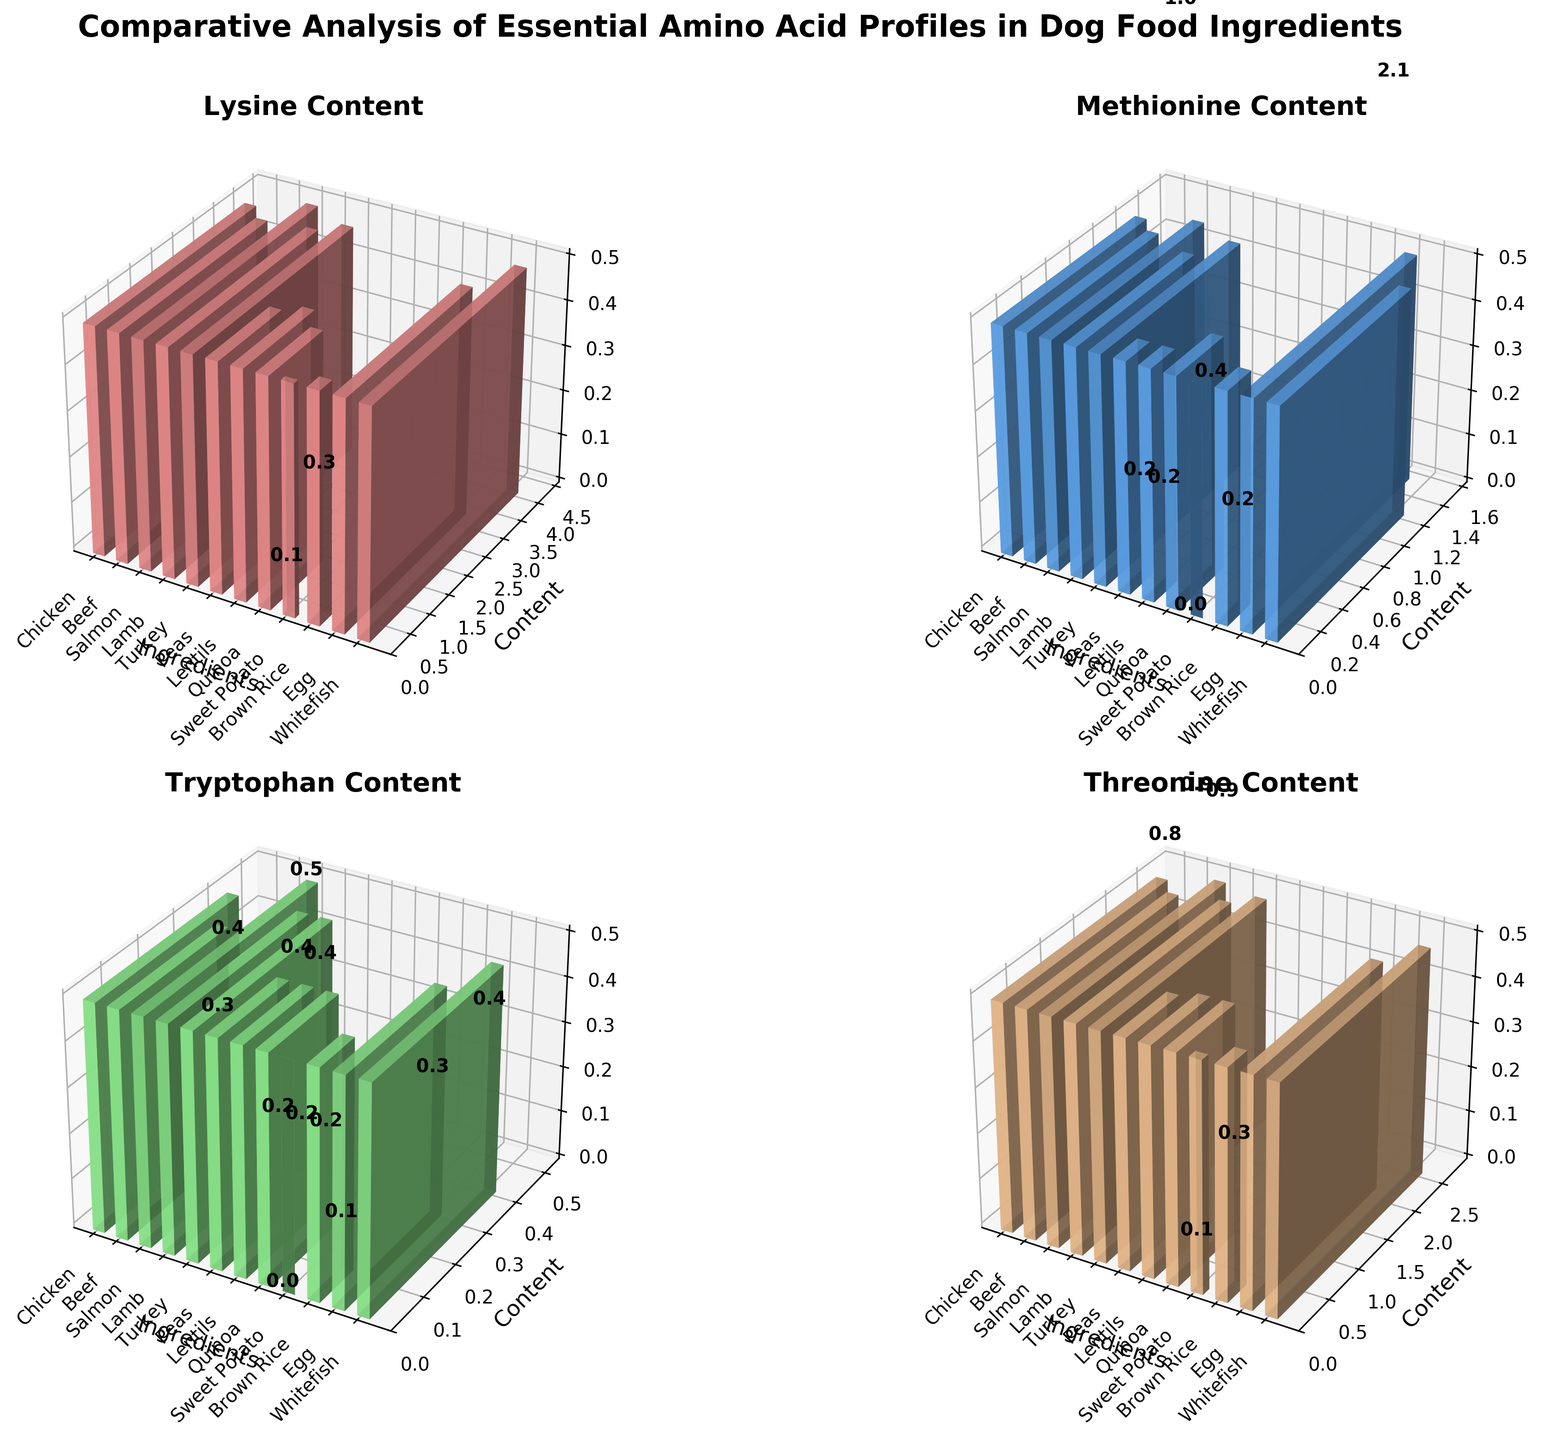What are the ingredient labels on the x-axis for the Lysine subplot? The Lysine subplot shows ingredients on the x-axis: Chicken, Beef, Salmon, Lamb, Turkey, Peas, Lentils, Quinoa, Sweet Potato, Brown Rice, Egg, and Whitefish.
Answer: Chicken, Beef, Salmon, Lamb, Turkey, Peas, Lentils, Quinoa, Sweet Potato, Brown Rice, Egg, Whitefish Which ingredient has the highest Threonine content? In the Threonine subplot, the bar for Salmon is the highest.
Answer: Salmon How does the Methionine content of Whitefish compare to that of Peas? In the Methionine subplot, the bar representing Whitefish is higher than the bar for Peas.
Answer: Whitefish is higher What is the average Lysine content across all ingredients? Sum the Lysine values (3.8 + 3.5 + 4.2 + 3.6 + 3.9 + 1.5 + 1.7 + 1.3 + 0.1 + 0.3 + 3.2 + 4.0 = 31.1) and divide by the number of ingredients (12). The average is 31.1 / 12.
Answer: 2.59 Compare the Tryptophan content between Beef and Lamb. Which is higher and by how much? From the Tryptophan subplot, Beef has 0.3 and Lamb has 0.4. The difference is 0.4 - 0.3 = 0.1. Lamb is higher by 0.1.
Answer: Lamb by 0.1 What is the total Methionine content for all plant-based ingredients? Sum the Methionine values for Peas, Lentils, Quinoa, Sweet Potato, and Brown Rice (0.2 + 0.2 + 0.4 + 0.0 + 0.2 = 1.0).
Answer: 1.0 Which amino acid has the smallest range of values across all ingredients? Calculate the range for each amino acid: Lysine (4.2 - 0.1 = 4.1), Methionine (1.5 - 0.0 = 1.5), Tryptophan (0.5 - 0.0 = 0.5), Threonine (2.7 - 0.1 = 2.6). Tryptophan has the smallest range of 0.5.
Answer: Tryptophan What is the difference in Threonine content between the ingredient with the highest value and the one with the lowest? Highest Threonine content is in Salmon (2.7) and the lowest is in Sweet Potato (0.1). The difference is 2.7 - 0.1 = 2.6.
Answer: 2.6 